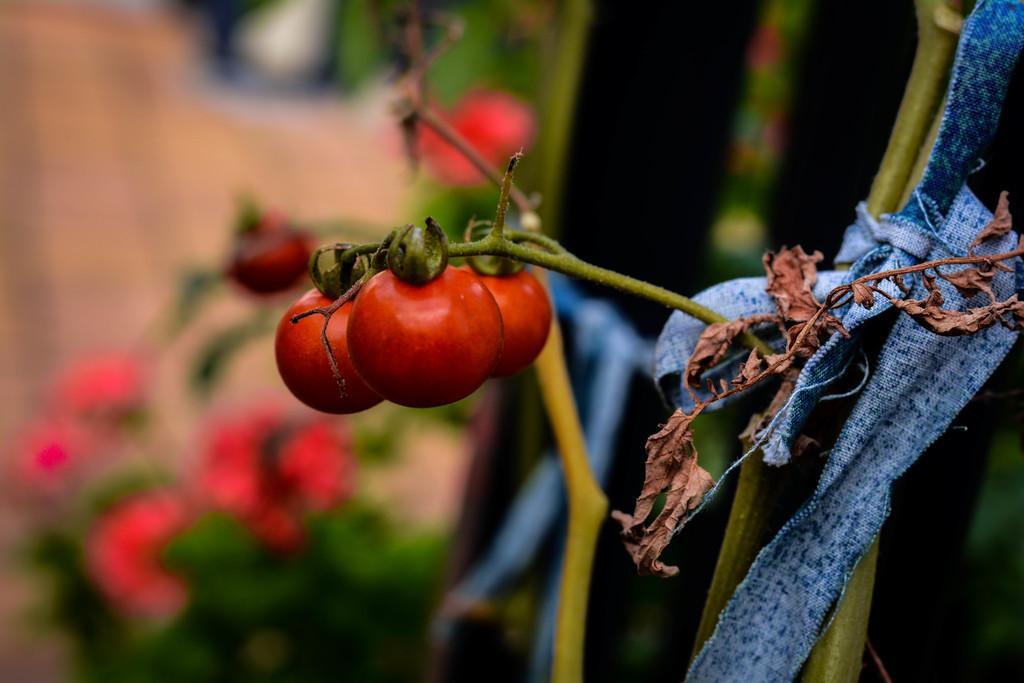Please provide a concise description of this image. In this picture I can see some tomatoes on the plant branch. On the right I can see some blue color cloth on this stick. On the left it might be the red flowers on the plant. At the top I can see the blur image. 